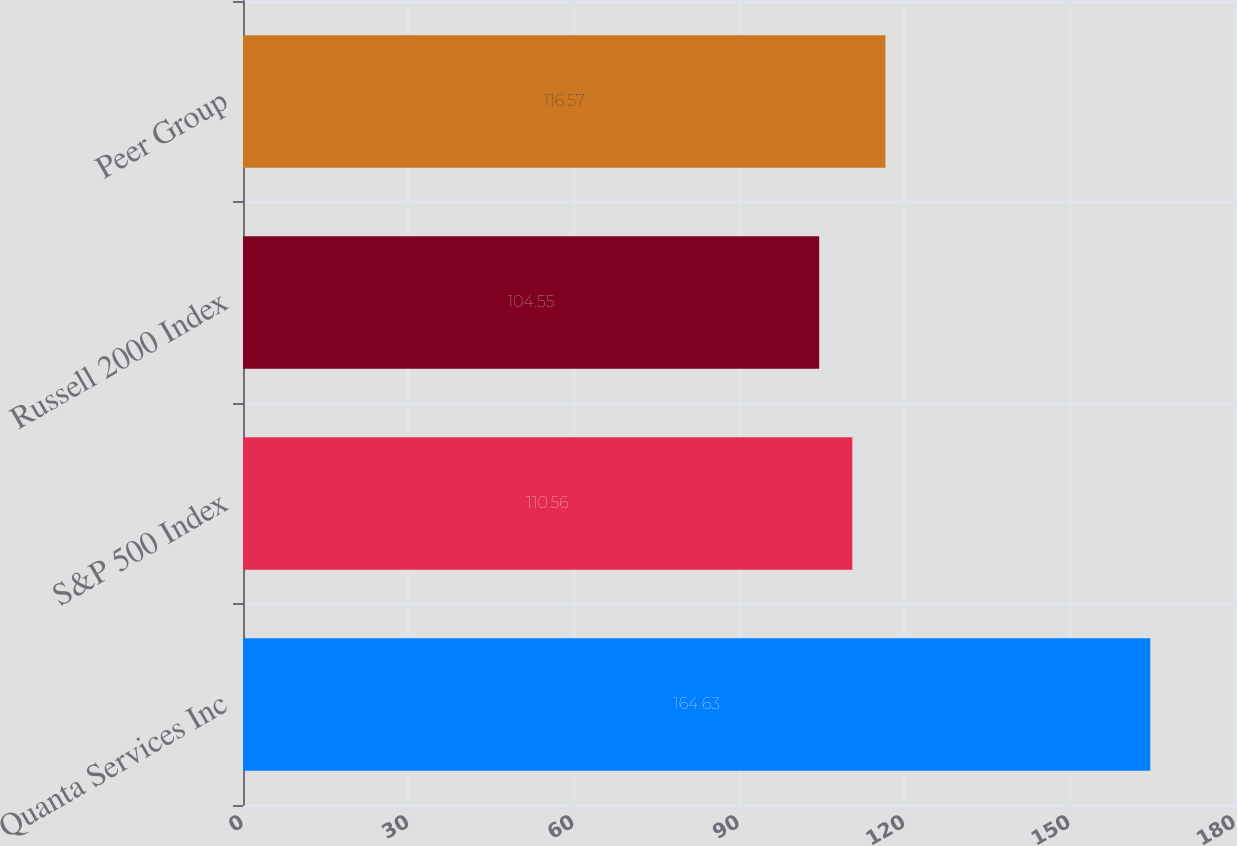Convert chart. <chart><loc_0><loc_0><loc_500><loc_500><bar_chart><fcel>Quanta Services Inc<fcel>S&P 500 Index<fcel>Russell 2000 Index<fcel>Peer Group<nl><fcel>164.63<fcel>110.56<fcel>104.55<fcel>116.57<nl></chart> 